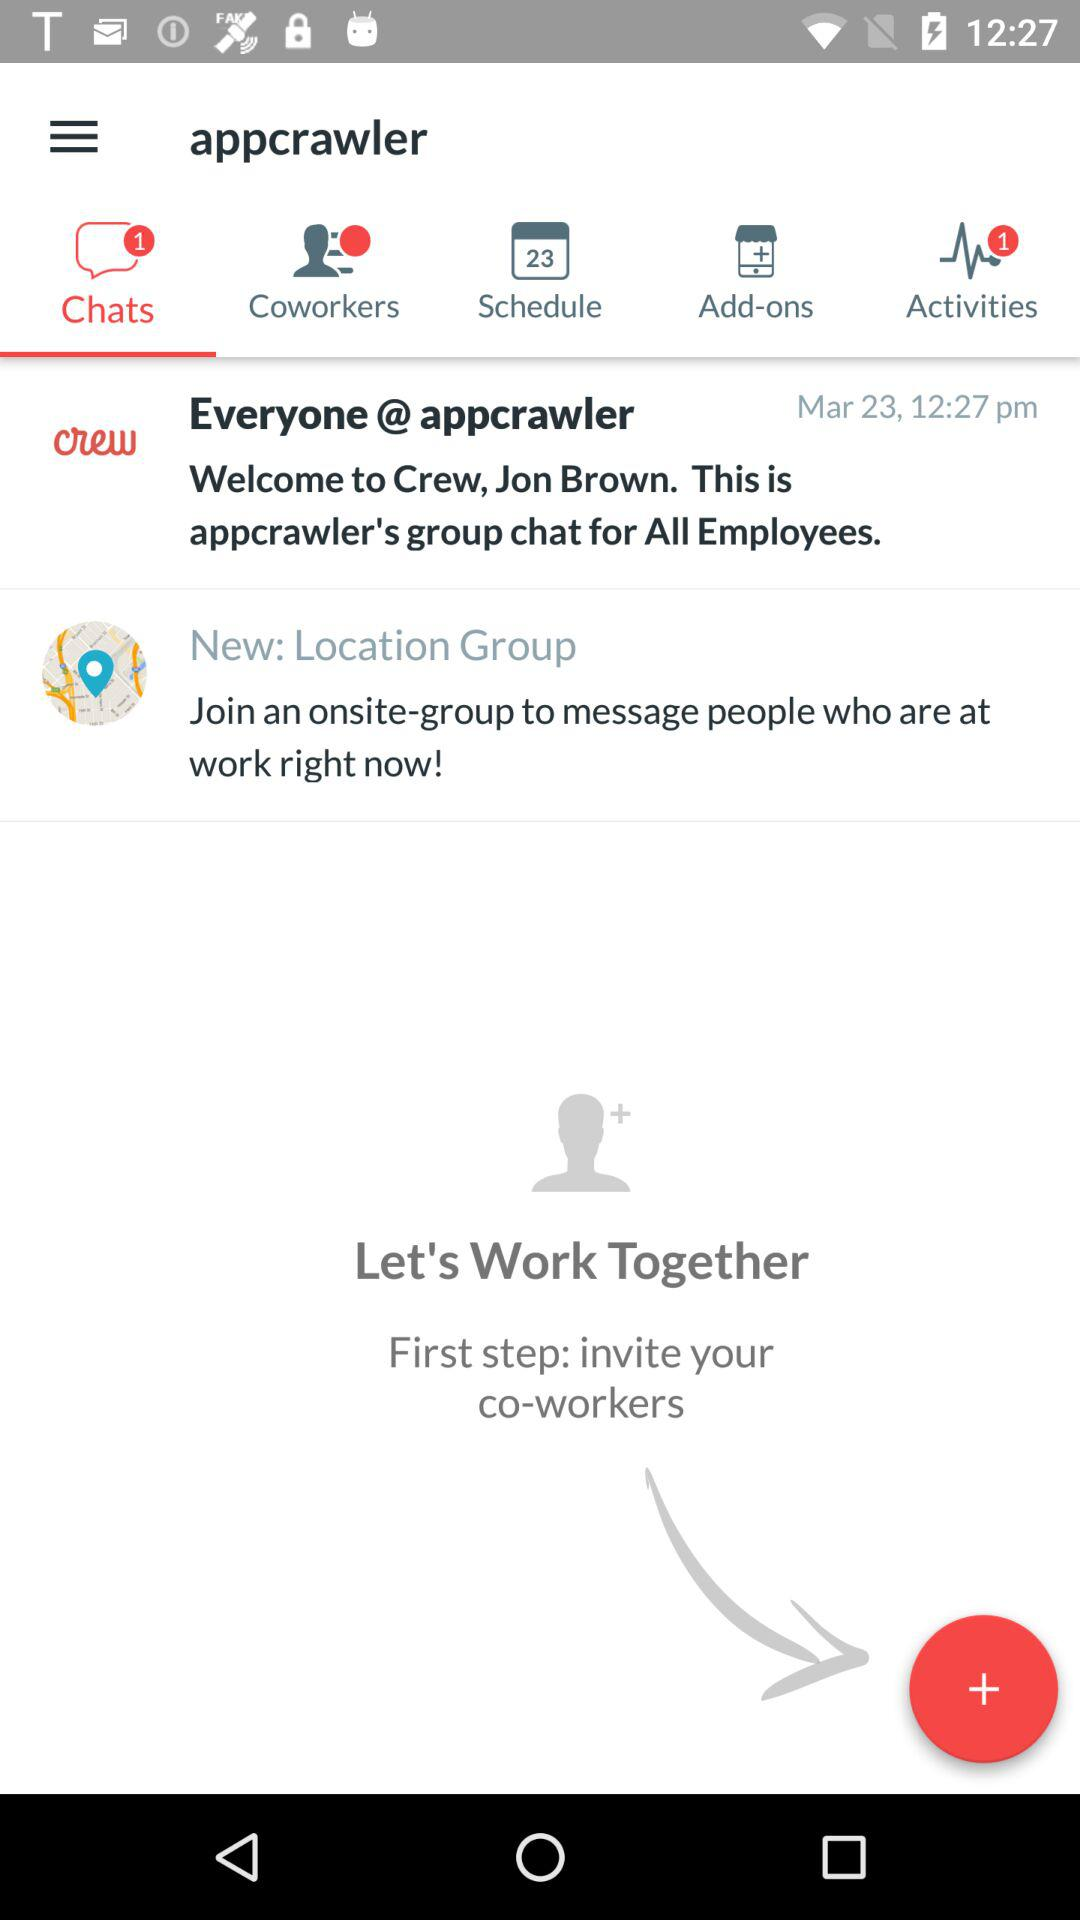Which tab am I using? You are using "Chats" tab. 